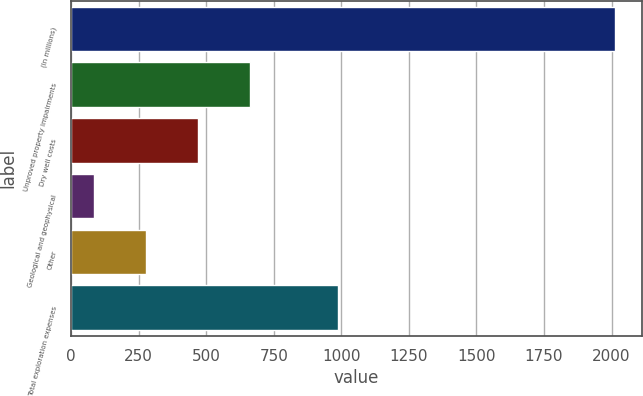Convert chart. <chart><loc_0><loc_0><loc_500><loc_500><bar_chart><fcel>(In millions)<fcel>Unproved property impairments<fcel>Dry well costs<fcel>Geological and geophysical<fcel>Other<fcel>Total exploration expenses<nl><fcel>2013<fcel>662.7<fcel>469.8<fcel>84<fcel>276.9<fcel>988<nl></chart> 